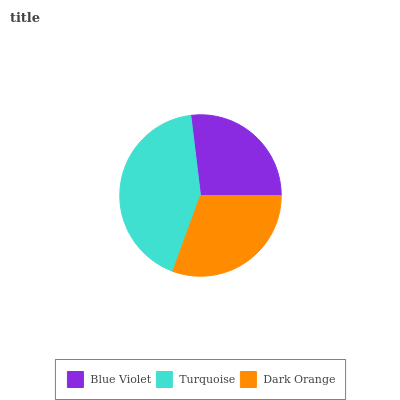Is Blue Violet the minimum?
Answer yes or no. Yes. Is Turquoise the maximum?
Answer yes or no. Yes. Is Dark Orange the minimum?
Answer yes or no. No. Is Dark Orange the maximum?
Answer yes or no. No. Is Turquoise greater than Dark Orange?
Answer yes or no. Yes. Is Dark Orange less than Turquoise?
Answer yes or no. Yes. Is Dark Orange greater than Turquoise?
Answer yes or no. No. Is Turquoise less than Dark Orange?
Answer yes or no. No. Is Dark Orange the high median?
Answer yes or no. Yes. Is Dark Orange the low median?
Answer yes or no. Yes. Is Turquoise the high median?
Answer yes or no. No. Is Turquoise the low median?
Answer yes or no. No. 